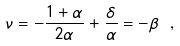<formula> <loc_0><loc_0><loc_500><loc_500>\nu = - \frac { 1 + \alpha } { 2 \alpha } + \frac { \delta } { \alpha } = - \beta \ ,</formula> 